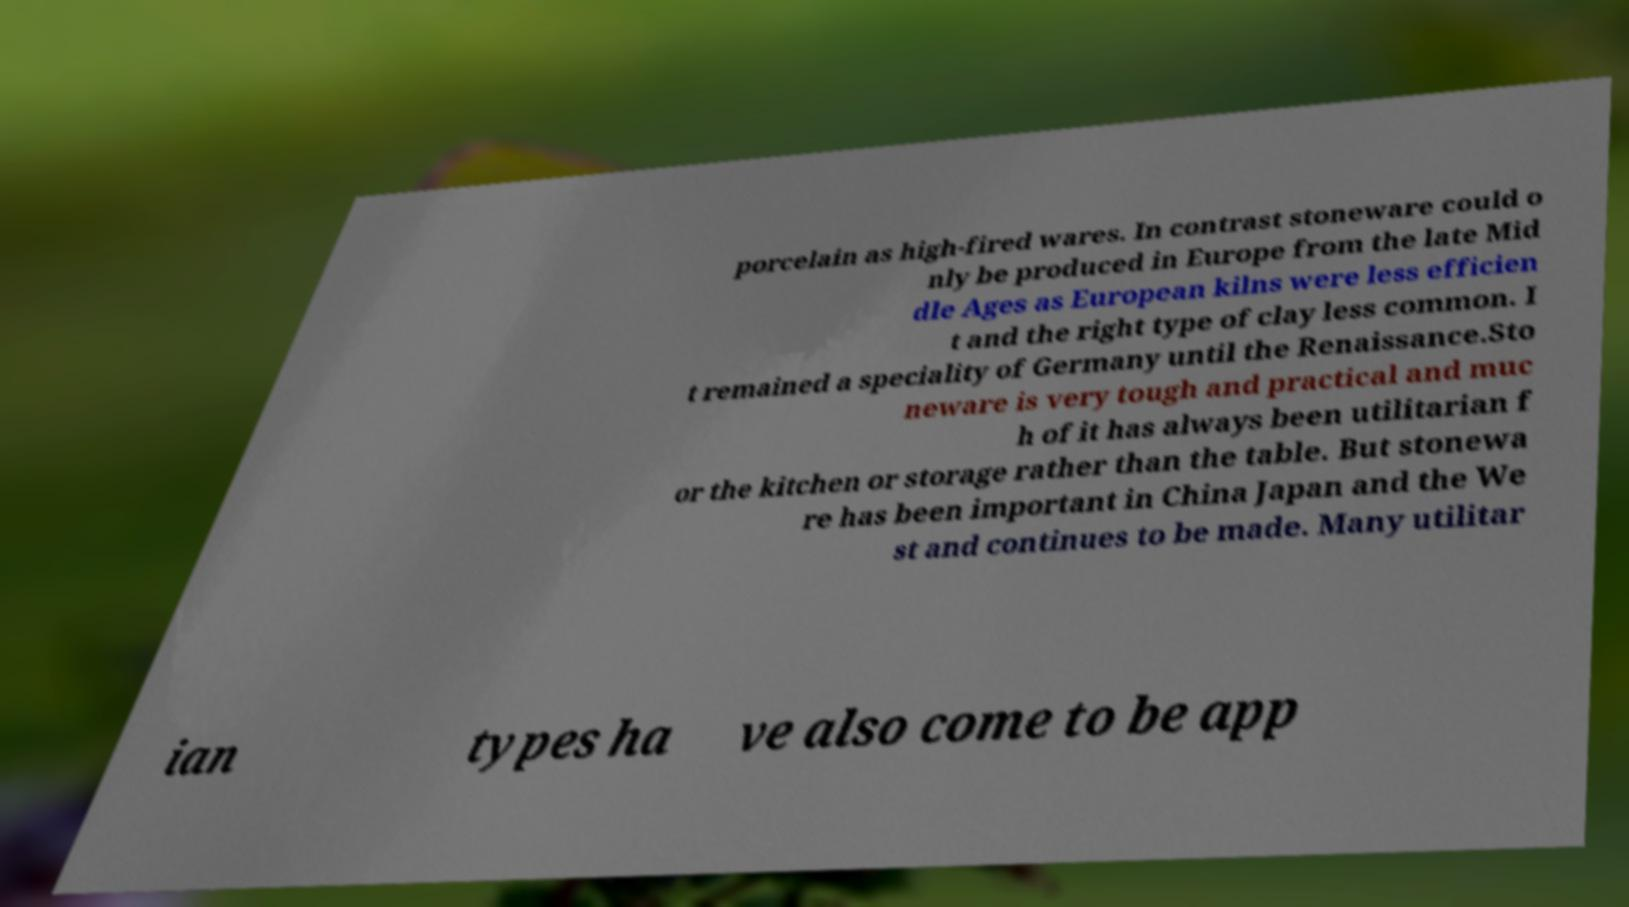What messages or text are displayed in this image? I need them in a readable, typed format. porcelain as high-fired wares. In contrast stoneware could o nly be produced in Europe from the late Mid dle Ages as European kilns were less efficien t and the right type of clay less common. I t remained a speciality of Germany until the Renaissance.Sto neware is very tough and practical and muc h of it has always been utilitarian f or the kitchen or storage rather than the table. But stonewa re has been important in China Japan and the We st and continues to be made. Many utilitar ian types ha ve also come to be app 